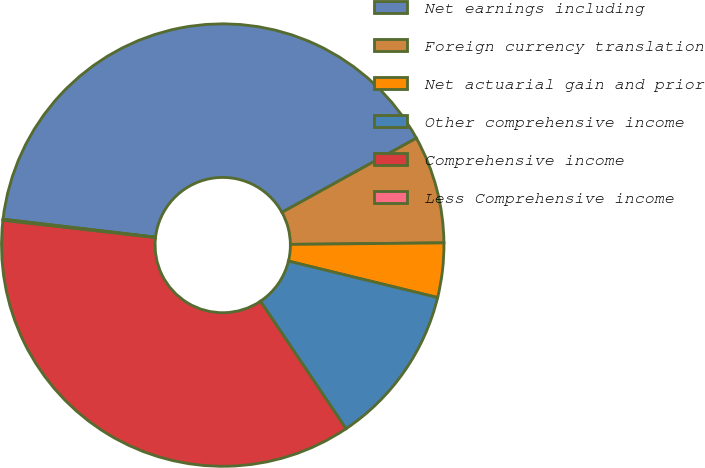Convert chart to OTSL. <chart><loc_0><loc_0><loc_500><loc_500><pie_chart><fcel>Net earnings including<fcel>Foreign currency translation<fcel>Net actuarial gain and prior<fcel>Other comprehensive income<fcel>Comprehensive income<fcel>Less Comprehensive income<nl><fcel>40.11%<fcel>7.87%<fcel>3.97%<fcel>11.78%<fcel>36.2%<fcel>0.07%<nl></chart> 